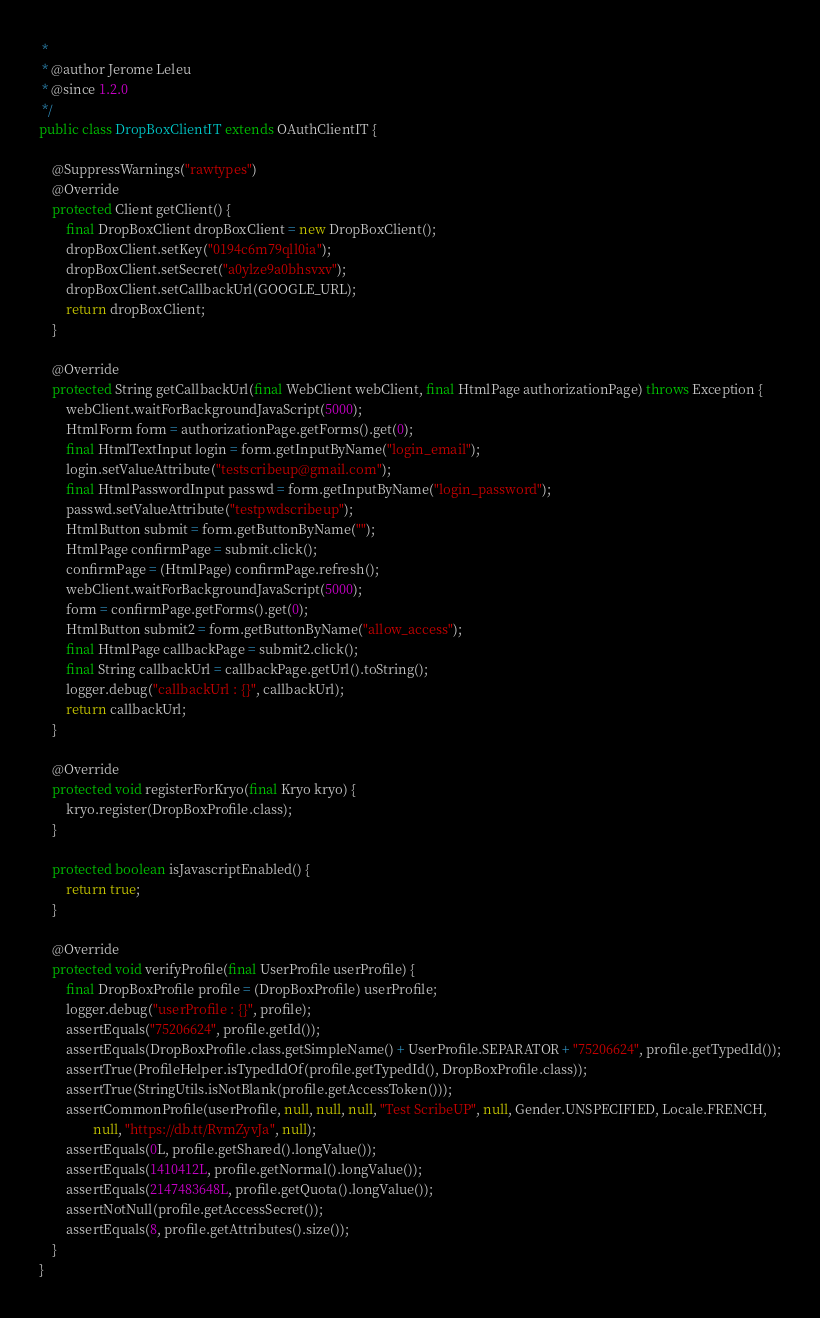<code> <loc_0><loc_0><loc_500><loc_500><_Java_> * 
 * @author Jerome Leleu
 * @since 1.2.0
 */
public class DropBoxClientIT extends OAuthClientIT {

    @SuppressWarnings("rawtypes")
    @Override
    protected Client getClient() {
        final DropBoxClient dropBoxClient = new DropBoxClient();
        dropBoxClient.setKey("0194c6m79qll0ia");
        dropBoxClient.setSecret("a0ylze9a0bhsvxv");
        dropBoxClient.setCallbackUrl(GOOGLE_URL);
        return dropBoxClient;
    }

    @Override
    protected String getCallbackUrl(final WebClient webClient, final HtmlPage authorizationPage) throws Exception {
        webClient.waitForBackgroundJavaScript(5000);
        HtmlForm form = authorizationPage.getForms().get(0);
        final HtmlTextInput login = form.getInputByName("login_email");
        login.setValueAttribute("testscribeup@gmail.com");
        final HtmlPasswordInput passwd = form.getInputByName("login_password");
        passwd.setValueAttribute("testpwdscribeup");
        HtmlButton submit = form.getButtonByName("");
        HtmlPage confirmPage = submit.click();
        confirmPage = (HtmlPage) confirmPage.refresh();
        webClient.waitForBackgroundJavaScript(5000);
        form = confirmPage.getForms().get(0);
        HtmlButton submit2 = form.getButtonByName("allow_access");
        final HtmlPage callbackPage = submit2.click();
        final String callbackUrl = callbackPage.getUrl().toString();
        logger.debug("callbackUrl : {}", callbackUrl);
        return callbackUrl;
    }

    @Override
    protected void registerForKryo(final Kryo kryo) {
        kryo.register(DropBoxProfile.class);
    }

    protected boolean isJavascriptEnabled() {
        return true;
    }

    @Override
    protected void verifyProfile(final UserProfile userProfile) {
        final DropBoxProfile profile = (DropBoxProfile) userProfile;
        logger.debug("userProfile : {}", profile);
        assertEquals("75206624", profile.getId());
        assertEquals(DropBoxProfile.class.getSimpleName() + UserProfile.SEPARATOR + "75206624", profile.getTypedId());
        assertTrue(ProfileHelper.isTypedIdOf(profile.getTypedId(), DropBoxProfile.class));
        assertTrue(StringUtils.isNotBlank(profile.getAccessToken()));
        assertCommonProfile(userProfile, null, null, null, "Test ScribeUP", null, Gender.UNSPECIFIED, Locale.FRENCH,
                null, "https://db.tt/RvmZyvJa", null);
        assertEquals(0L, profile.getShared().longValue());
        assertEquals(1410412L, profile.getNormal().longValue());
        assertEquals(2147483648L, profile.getQuota().longValue());
        assertNotNull(profile.getAccessSecret());
        assertEquals(8, profile.getAttributes().size());
    }
}
</code> 